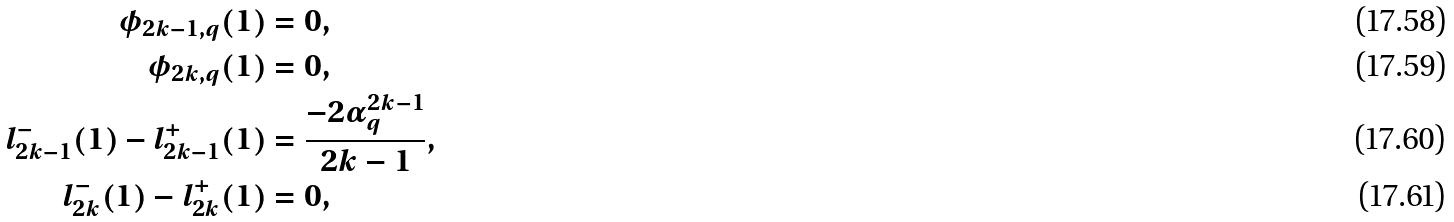<formula> <loc_0><loc_0><loc_500><loc_500>\phi _ { 2 k - 1 , q } ( 1 ) & = 0 , \\ \phi _ { 2 k , q } ( 1 ) & = 0 , \\ l ^ { - } _ { 2 k - 1 } ( 1 ) - l ^ { + } _ { 2 k - 1 } ( 1 ) & = \frac { - 2 \alpha _ { q } ^ { 2 k - 1 } } { 2 k - 1 } , \\ l ^ { - } _ { 2 k } ( 1 ) - l ^ { + } _ { 2 k } ( 1 ) & = 0 ,</formula> 